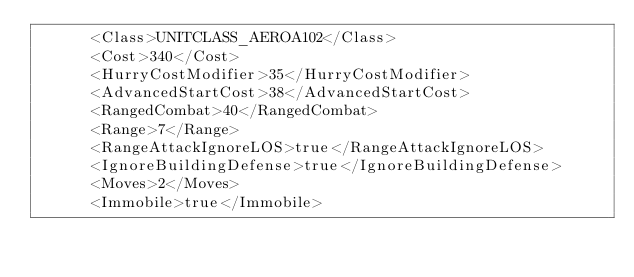<code> <loc_0><loc_0><loc_500><loc_500><_XML_>      <Class>UNITCLASS_AEROA102</Class>
      <Cost>340</Cost>
      <HurryCostModifier>35</HurryCostModifier>
      <AdvancedStartCost>38</AdvancedStartCost>
      <RangedCombat>40</RangedCombat>
      <Range>7</Range>
      <RangeAttackIgnoreLOS>true</RangeAttackIgnoreLOS>
      <IgnoreBuildingDefense>true</IgnoreBuildingDefense>
      <Moves>2</Moves>
      <Immobile>true</Immobile></code> 